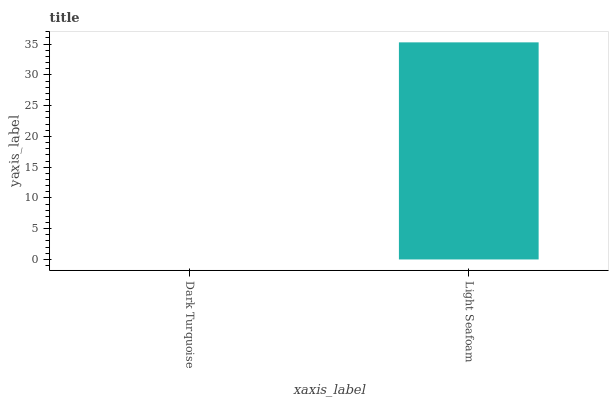Is Light Seafoam the minimum?
Answer yes or no. No. Is Light Seafoam greater than Dark Turquoise?
Answer yes or no. Yes. Is Dark Turquoise less than Light Seafoam?
Answer yes or no. Yes. Is Dark Turquoise greater than Light Seafoam?
Answer yes or no. No. Is Light Seafoam less than Dark Turquoise?
Answer yes or no. No. Is Light Seafoam the high median?
Answer yes or no. Yes. Is Dark Turquoise the low median?
Answer yes or no. Yes. Is Dark Turquoise the high median?
Answer yes or no. No. Is Light Seafoam the low median?
Answer yes or no. No. 